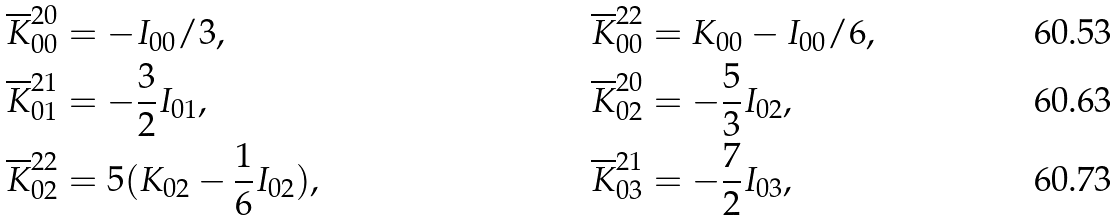Convert formula to latex. <formula><loc_0><loc_0><loc_500><loc_500>& \overline { K } ^ { 2 0 } _ { 0 0 } = - I _ { 0 0 } / 3 , \quad & & \overline { K } ^ { 2 2 } _ { 0 0 } = K _ { 0 0 } - I _ { 0 0 } / 6 , \\ & \overline { K } ^ { 2 1 } _ { 0 1 } = - \frac { 3 } { 2 } I _ { 0 1 } , \quad & & \overline { K } ^ { 2 0 } _ { 0 2 } = - \frac { 5 } { 3 } I _ { 0 2 } , \\ & \overline { K } ^ { 2 2 } _ { 0 2 } = 5 ( K _ { 0 2 } - \frac { 1 } { 6 } I _ { 0 2 } ) , \quad & & \overline { K } ^ { 2 1 } _ { 0 3 } = - \frac { 7 } { 2 } I _ { 0 3 } ,</formula> 